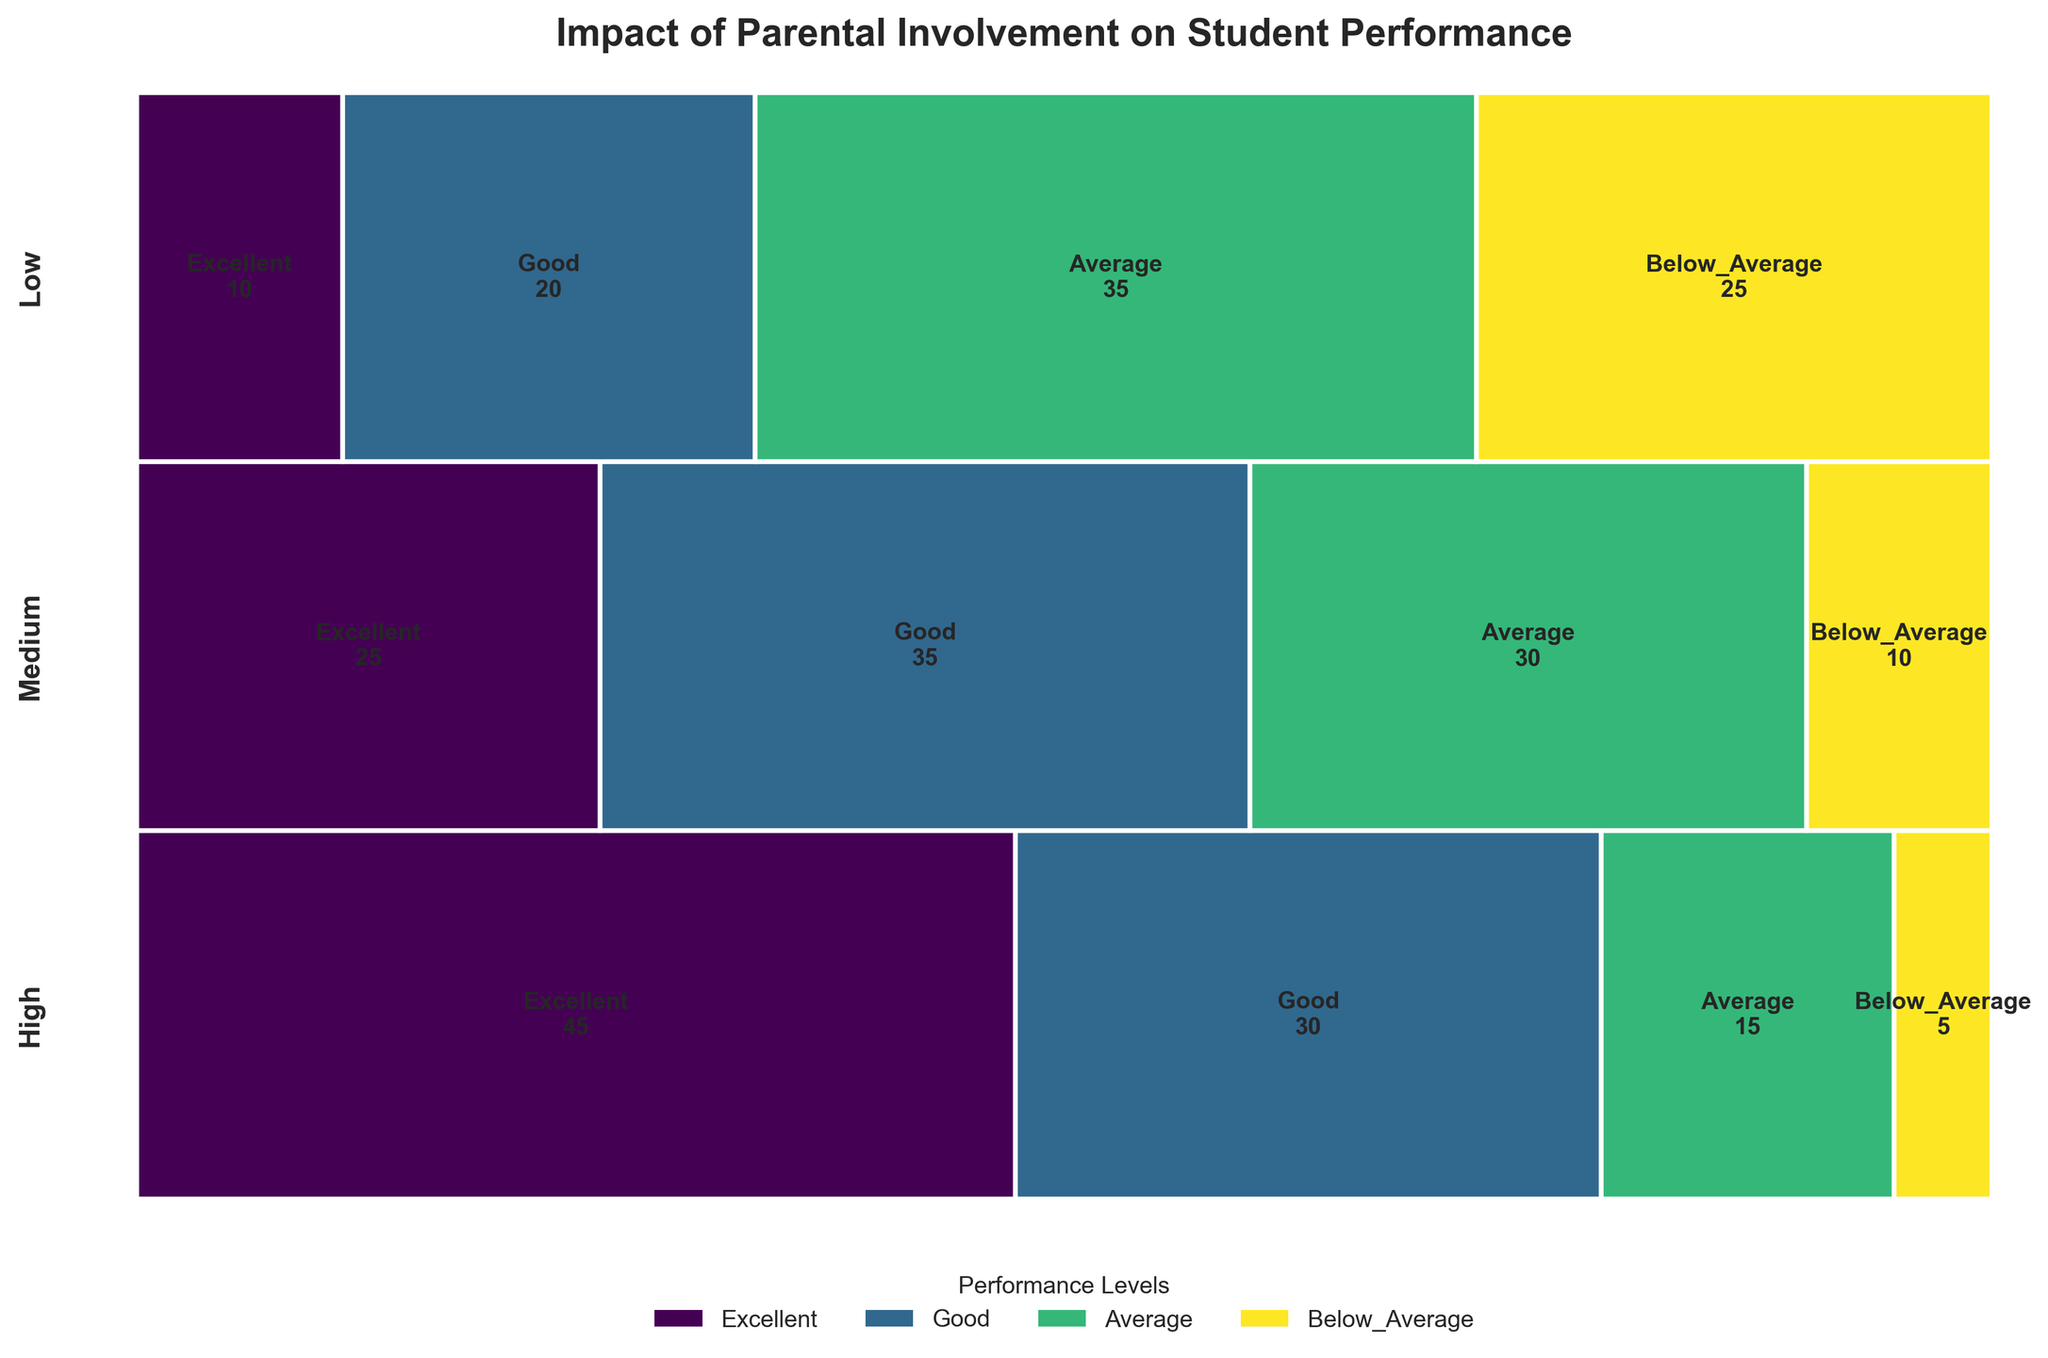What's the title of the figure? The title is usually found at the top of the figure as a heading. In this case, the title is explicitly set in the code.
Answer: Impact of Parental Involvement on Student Performance How does parental involvement affect the chances of a student achieving 'Excellent' performance? Look at the proportion of 'Excellent' performance within each involvement level in the mosaic plot. The width of 'Excellent' decreases from High to Low involvement, indicating diminishing chances.
Answer: Higher involvement increases chances What is the total number of students with 'Good' performance? Sum all the students labeled as 'Good' across different involvement levels. The numbers are 30 (High), 35 (Medium), and 20 (Low).
Answer: 85 Which performance level has the highest number of students in the 'Low' involvement category? Compare the widths of each performance level within the 'Low' parental involvement category in the mosaic plot. The widest bar denotes the highest count.
Answer: Average How does 'Average' performance compare between 'Medium' and 'Low' parental involvement? Compare the widths of the 'Average' performance bars for both 'Medium' and 'Low' parental involvement levels. The 'Low' involvement bar is wider.
Answer: More students with 'Low' involvement Which performance level has the least number of students in the 'High' parental involvement category? Identify the narrowest bar within the 'High' parental involvement section. The smallest width indicates the least number of students.
Answer: Below Average For 'Medium' parental involvement, which performance level has the closest student count to 'Good'? Examine the 'Medium' involvement section and compare widths of performance levels. 'Good' has 35 students; 'Average' is next with 30 students close to 'Good'.
Answer: Average How many more students achieve 'Excellent' performance with 'High' involvement than 'Medium'? Subtract the number of 'Excellent' students in 'Medium' involvement from 'High'. The difference between 45 (High) and 25 (Medium) is calculated.
Answer: 20 What percentage of students have 'Below_Average' performance with 'Low' involvement? Calculate the percentage as (number of 'Below_Average' in Low / total in Low) * 100. The figures are 25 and 90, respectively.
Answer: 27.78% In which involvement category do students have the highest probability of 'Excellent' performance? Compare the widths of 'Excellent' performance bars across all involvement levels. The widest bar is for 'High' involvement.
Answer: High 